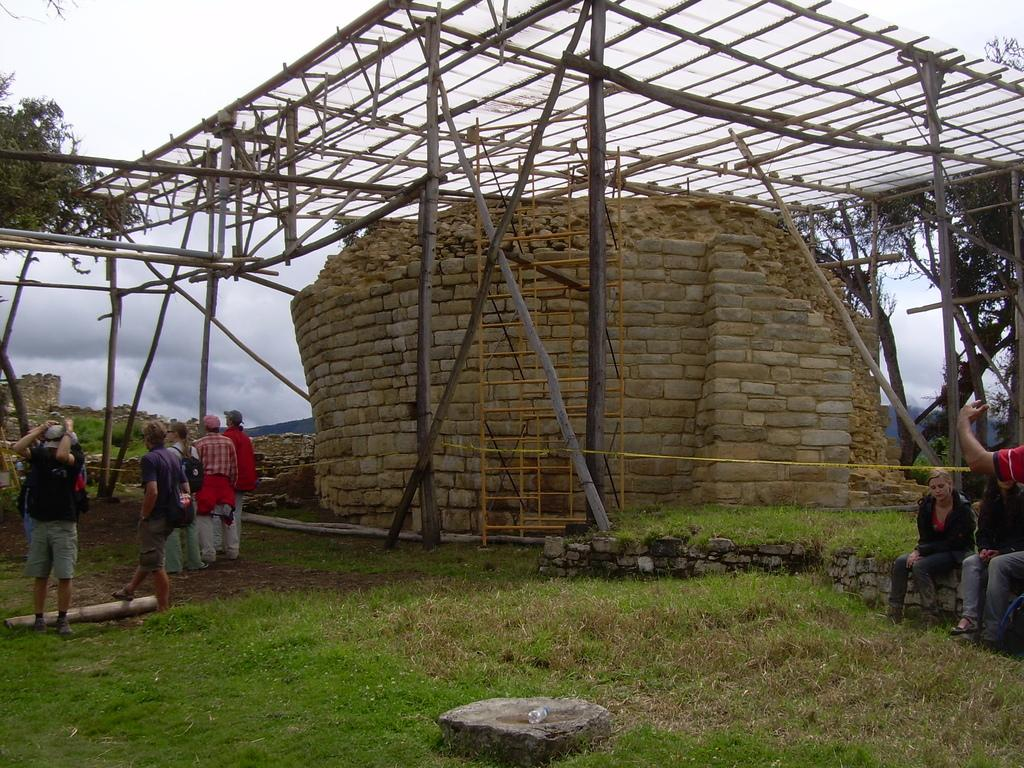What type of roof is visible in the image? There is a wooden roof in the image. What type of wall can be seen in the image? There is a brick wall in the image. What are the people in the image doing? People are sitting and standing on the right and left sides of the image. What type of vegetation is present in the image? Trees are present in the image. What is the condition of the sky in the image? The sky is full of clouds. Can you see any flowers growing on the wire in the image? There is no wire present in the image, and therefore no flowers growing on it. What type of airplane is flying in the image? There is no airplane visible in the image. 